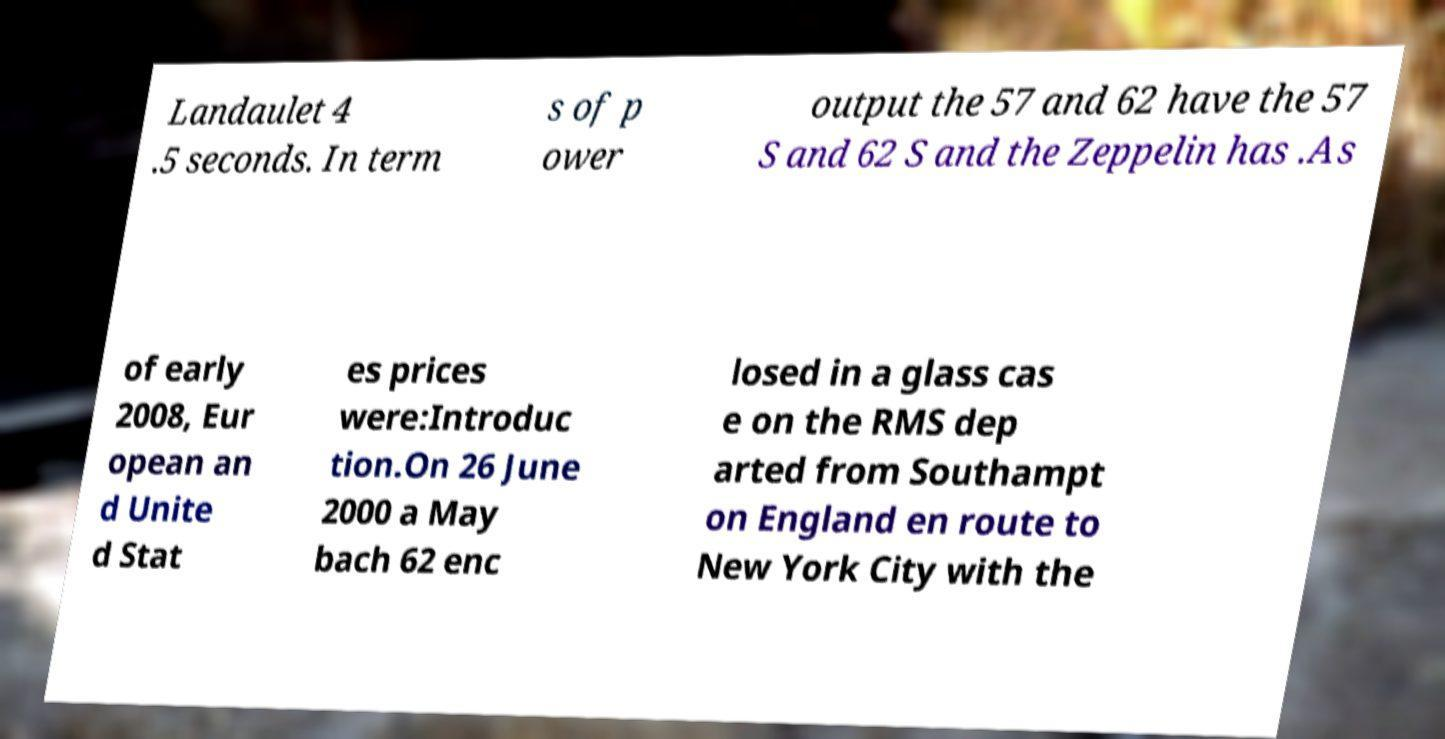Please read and relay the text visible in this image. What does it say? Landaulet 4 .5 seconds. In term s of p ower output the 57 and 62 have the 57 S and 62 S and the Zeppelin has .As of early 2008, Eur opean an d Unite d Stat es prices were:Introduc tion.On 26 June 2000 a May bach 62 enc losed in a glass cas e on the RMS dep arted from Southampt on England en route to New York City with the 